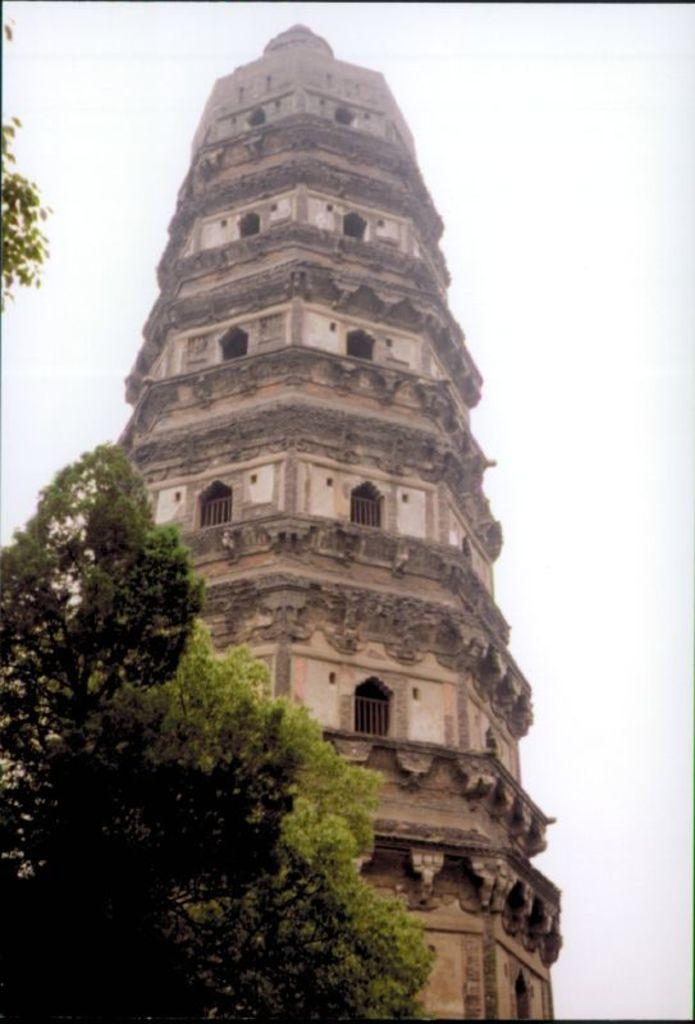What is the main structure visible in the image? There is a tower in the image. What type of vegetation is present in the image? There are plants in the image. What country is depicted in the image? The image does not depict any specific country; it only features a tower and plants. What belief system is represented in the image? The image does not represent any specific belief system; it only features a tower and plants. 